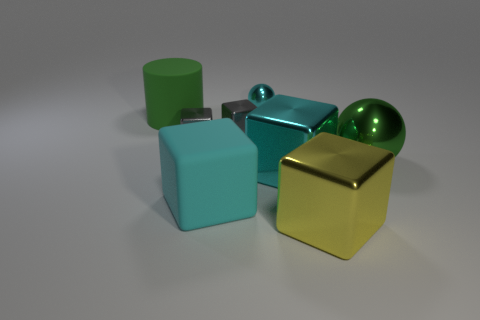Add 1 gray rubber cylinders. How many objects exist? 9 Subtract all large cyan metallic blocks. How many blocks are left? 4 Subtract all red balls. How many cyan blocks are left? 2 Subtract 2 spheres. How many spheres are left? 0 Subtract all spheres. How many objects are left? 6 Subtract all gray blocks. How many blocks are left? 3 Subtract 0 purple blocks. How many objects are left? 8 Subtract all gray cylinders. Subtract all yellow cubes. How many cylinders are left? 1 Subtract all small yellow blocks. Subtract all small gray shiny cubes. How many objects are left? 6 Add 6 small spheres. How many small spheres are left? 7 